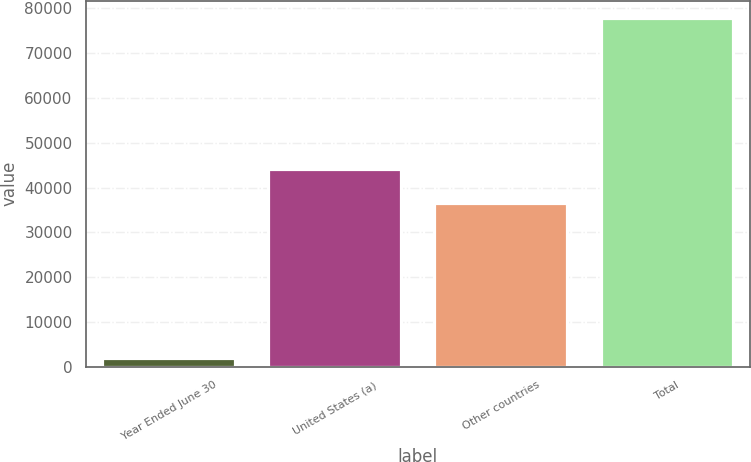<chart> <loc_0><loc_0><loc_500><loc_500><bar_chart><fcel>Year Ended June 30<fcel>United States (a)<fcel>Other countries<fcel>Total<nl><fcel>2013<fcel>44088.6<fcel>36505<fcel>77849<nl></chart> 